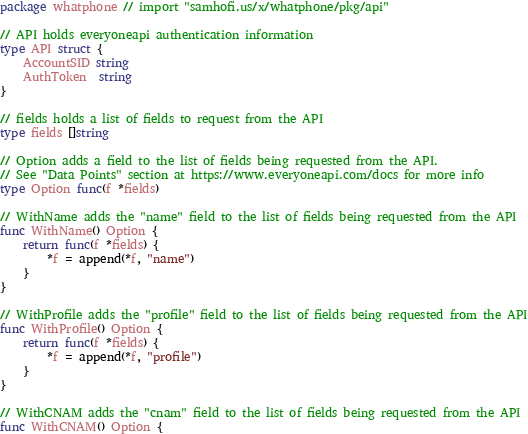Convert code to text. <code><loc_0><loc_0><loc_500><loc_500><_Go_>package whatphone // import "samhofi.us/x/whatphone/pkg/api"

// API holds everyoneapi authentication information
type API struct {
	AccountSID string
	AuthToken  string
}

// fields holds a list of fields to request from the API
type fields []string

// Option adds a field to the list of fields being requested from the API.
// See "Data Points" section at https://www.everyoneapi.com/docs for more info
type Option func(f *fields)

// WithName adds the "name" field to the list of fields being requested from the API
func WithName() Option {
	return func(f *fields) {
		*f = append(*f, "name")
	}
}

// WithProfile adds the "profile" field to the list of fields being requested from the API
func WithProfile() Option {
	return func(f *fields) {
		*f = append(*f, "profile")
	}
}

// WithCNAM adds the "cnam" field to the list of fields being requested from the API
func WithCNAM() Option {</code> 